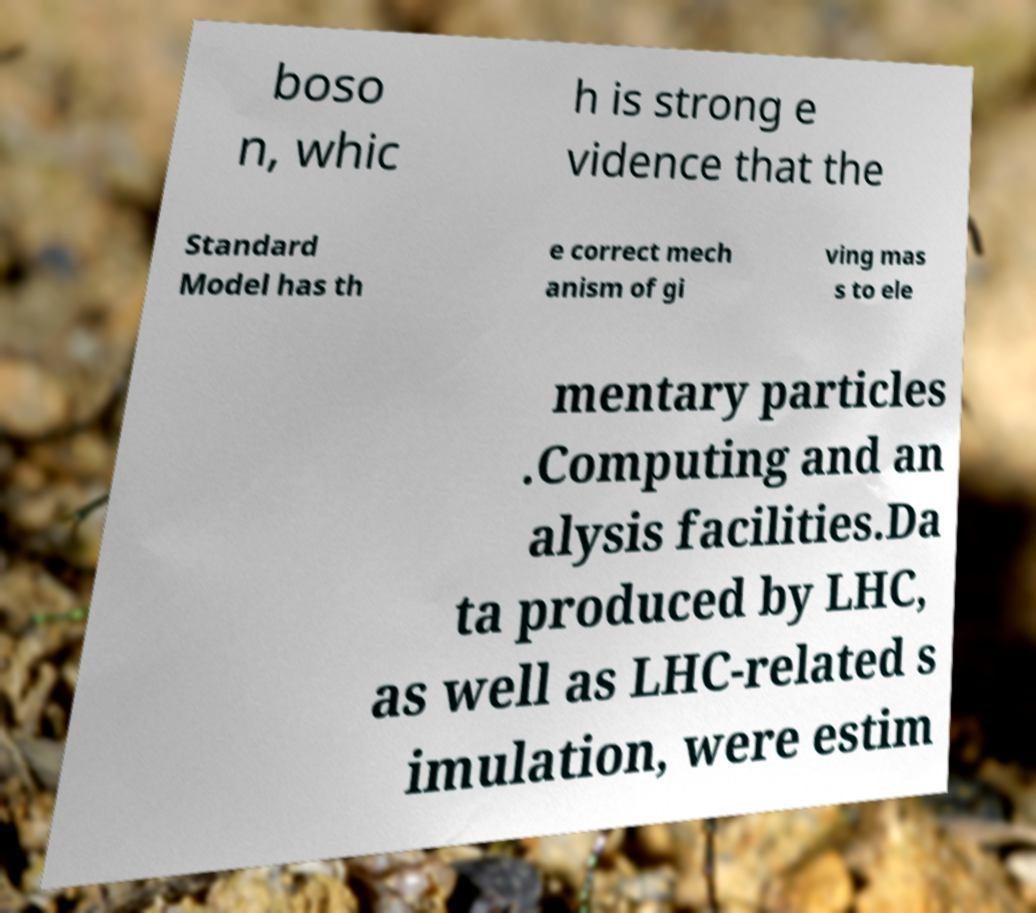For documentation purposes, I need the text within this image transcribed. Could you provide that? boso n, whic h is strong e vidence that the Standard Model has th e correct mech anism of gi ving mas s to ele mentary particles .Computing and an alysis facilities.Da ta produced by LHC, as well as LHC-related s imulation, were estim 